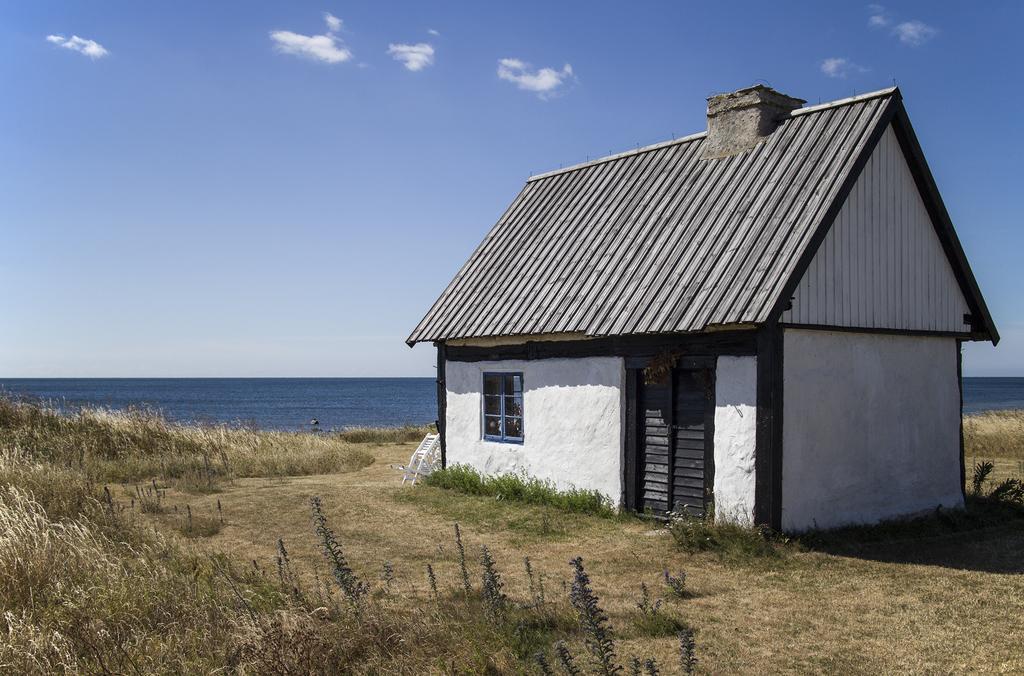In one or two sentences, can you explain what this image depicts? In this image we can see a house. In the foreground there are groups of plants. Behind the house we can see the water. At the top we can see the sky. 